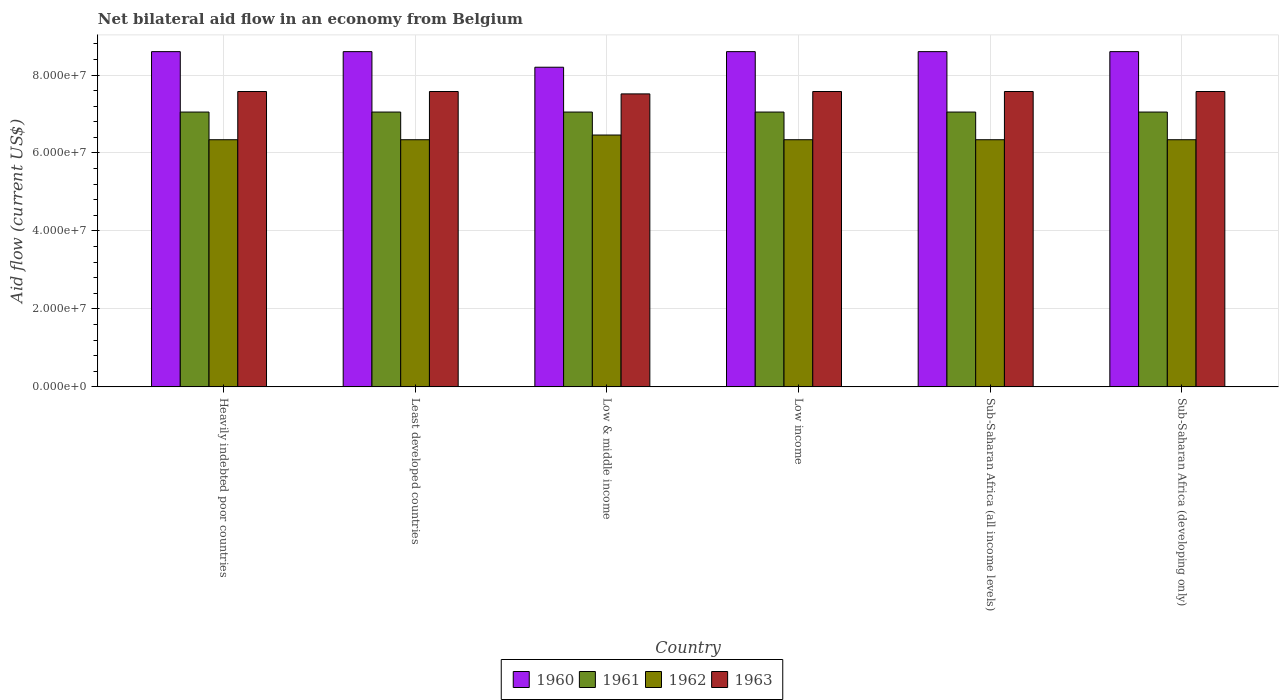Are the number of bars per tick equal to the number of legend labels?
Your answer should be compact. Yes. In how many cases, is the number of bars for a given country not equal to the number of legend labels?
Your response must be concise. 0. What is the net bilateral aid flow in 1962 in Sub-Saharan Africa (developing only)?
Provide a short and direct response. 6.34e+07. Across all countries, what is the maximum net bilateral aid flow in 1960?
Offer a very short reply. 8.60e+07. Across all countries, what is the minimum net bilateral aid flow in 1963?
Your answer should be very brief. 7.52e+07. In which country was the net bilateral aid flow in 1961 maximum?
Ensure brevity in your answer.  Heavily indebted poor countries. In which country was the net bilateral aid flow in 1960 minimum?
Offer a terse response. Low & middle income. What is the total net bilateral aid flow in 1960 in the graph?
Keep it short and to the point. 5.12e+08. What is the difference between the net bilateral aid flow in 1960 in Heavily indebted poor countries and that in Sub-Saharan Africa (developing only)?
Make the answer very short. 0. What is the difference between the net bilateral aid flow in 1962 in Sub-Saharan Africa (all income levels) and the net bilateral aid flow in 1963 in Sub-Saharan Africa (developing only)?
Offer a terse response. -1.24e+07. What is the average net bilateral aid flow in 1963 per country?
Provide a succinct answer. 7.57e+07. What is the difference between the net bilateral aid flow of/in 1963 and net bilateral aid flow of/in 1962 in Least developed countries?
Keep it short and to the point. 1.24e+07. In how many countries, is the net bilateral aid flow in 1963 greater than 24000000 US$?
Provide a succinct answer. 6. What is the ratio of the net bilateral aid flow in 1960 in Heavily indebted poor countries to that in Least developed countries?
Ensure brevity in your answer.  1. Is the net bilateral aid flow in 1962 in Sub-Saharan Africa (all income levels) less than that in Sub-Saharan Africa (developing only)?
Provide a succinct answer. No. Is the difference between the net bilateral aid flow in 1963 in Sub-Saharan Africa (all income levels) and Sub-Saharan Africa (developing only) greater than the difference between the net bilateral aid flow in 1962 in Sub-Saharan Africa (all income levels) and Sub-Saharan Africa (developing only)?
Provide a succinct answer. No. What is the difference between the highest and the second highest net bilateral aid flow in 1962?
Ensure brevity in your answer.  1.21e+06. What does the 2nd bar from the left in Sub-Saharan Africa (all income levels) represents?
Your response must be concise. 1961. Is it the case that in every country, the sum of the net bilateral aid flow in 1960 and net bilateral aid flow in 1961 is greater than the net bilateral aid flow in 1963?
Your answer should be compact. Yes. How many countries are there in the graph?
Keep it short and to the point. 6. What is the difference between two consecutive major ticks on the Y-axis?
Give a very brief answer. 2.00e+07. Does the graph contain any zero values?
Your answer should be compact. No. Where does the legend appear in the graph?
Provide a succinct answer. Bottom center. How many legend labels are there?
Your answer should be compact. 4. What is the title of the graph?
Give a very brief answer. Net bilateral aid flow in an economy from Belgium. Does "1993" appear as one of the legend labels in the graph?
Provide a short and direct response. No. What is the Aid flow (current US$) in 1960 in Heavily indebted poor countries?
Make the answer very short. 8.60e+07. What is the Aid flow (current US$) in 1961 in Heavily indebted poor countries?
Keep it short and to the point. 7.05e+07. What is the Aid flow (current US$) in 1962 in Heavily indebted poor countries?
Provide a short and direct response. 6.34e+07. What is the Aid flow (current US$) of 1963 in Heavily indebted poor countries?
Offer a very short reply. 7.58e+07. What is the Aid flow (current US$) in 1960 in Least developed countries?
Give a very brief answer. 8.60e+07. What is the Aid flow (current US$) of 1961 in Least developed countries?
Keep it short and to the point. 7.05e+07. What is the Aid flow (current US$) in 1962 in Least developed countries?
Ensure brevity in your answer.  6.34e+07. What is the Aid flow (current US$) of 1963 in Least developed countries?
Make the answer very short. 7.58e+07. What is the Aid flow (current US$) in 1960 in Low & middle income?
Your response must be concise. 8.20e+07. What is the Aid flow (current US$) in 1961 in Low & middle income?
Provide a succinct answer. 7.05e+07. What is the Aid flow (current US$) in 1962 in Low & middle income?
Your answer should be very brief. 6.46e+07. What is the Aid flow (current US$) in 1963 in Low & middle income?
Give a very brief answer. 7.52e+07. What is the Aid flow (current US$) of 1960 in Low income?
Offer a terse response. 8.60e+07. What is the Aid flow (current US$) in 1961 in Low income?
Offer a very short reply. 7.05e+07. What is the Aid flow (current US$) of 1962 in Low income?
Your answer should be very brief. 6.34e+07. What is the Aid flow (current US$) of 1963 in Low income?
Give a very brief answer. 7.58e+07. What is the Aid flow (current US$) in 1960 in Sub-Saharan Africa (all income levels)?
Give a very brief answer. 8.60e+07. What is the Aid flow (current US$) of 1961 in Sub-Saharan Africa (all income levels)?
Give a very brief answer. 7.05e+07. What is the Aid flow (current US$) of 1962 in Sub-Saharan Africa (all income levels)?
Your answer should be compact. 6.34e+07. What is the Aid flow (current US$) of 1963 in Sub-Saharan Africa (all income levels)?
Offer a terse response. 7.58e+07. What is the Aid flow (current US$) in 1960 in Sub-Saharan Africa (developing only)?
Provide a succinct answer. 8.60e+07. What is the Aid flow (current US$) in 1961 in Sub-Saharan Africa (developing only)?
Make the answer very short. 7.05e+07. What is the Aid flow (current US$) in 1962 in Sub-Saharan Africa (developing only)?
Provide a succinct answer. 6.34e+07. What is the Aid flow (current US$) in 1963 in Sub-Saharan Africa (developing only)?
Make the answer very short. 7.58e+07. Across all countries, what is the maximum Aid flow (current US$) in 1960?
Your response must be concise. 8.60e+07. Across all countries, what is the maximum Aid flow (current US$) of 1961?
Provide a succinct answer. 7.05e+07. Across all countries, what is the maximum Aid flow (current US$) of 1962?
Give a very brief answer. 6.46e+07. Across all countries, what is the maximum Aid flow (current US$) in 1963?
Your response must be concise. 7.58e+07. Across all countries, what is the minimum Aid flow (current US$) of 1960?
Your answer should be compact. 8.20e+07. Across all countries, what is the minimum Aid flow (current US$) in 1961?
Keep it short and to the point. 7.05e+07. Across all countries, what is the minimum Aid flow (current US$) in 1962?
Provide a succinct answer. 6.34e+07. Across all countries, what is the minimum Aid flow (current US$) of 1963?
Offer a terse response. 7.52e+07. What is the total Aid flow (current US$) of 1960 in the graph?
Offer a very short reply. 5.12e+08. What is the total Aid flow (current US$) of 1961 in the graph?
Offer a terse response. 4.23e+08. What is the total Aid flow (current US$) of 1962 in the graph?
Give a very brief answer. 3.82e+08. What is the total Aid flow (current US$) in 1963 in the graph?
Offer a terse response. 4.54e+08. What is the difference between the Aid flow (current US$) in 1961 in Heavily indebted poor countries and that in Least developed countries?
Your answer should be compact. 0. What is the difference between the Aid flow (current US$) of 1960 in Heavily indebted poor countries and that in Low & middle income?
Your answer should be compact. 4.00e+06. What is the difference between the Aid flow (current US$) of 1961 in Heavily indebted poor countries and that in Low & middle income?
Make the answer very short. 0. What is the difference between the Aid flow (current US$) of 1962 in Heavily indebted poor countries and that in Low & middle income?
Your answer should be very brief. -1.21e+06. What is the difference between the Aid flow (current US$) of 1963 in Heavily indebted poor countries and that in Low & middle income?
Make the answer very short. 6.10e+05. What is the difference between the Aid flow (current US$) of 1960 in Heavily indebted poor countries and that in Sub-Saharan Africa (all income levels)?
Your response must be concise. 0. What is the difference between the Aid flow (current US$) of 1962 in Least developed countries and that in Low & middle income?
Give a very brief answer. -1.21e+06. What is the difference between the Aid flow (current US$) of 1962 in Least developed countries and that in Low income?
Your answer should be very brief. 0. What is the difference between the Aid flow (current US$) of 1960 in Least developed countries and that in Sub-Saharan Africa (all income levels)?
Your answer should be very brief. 0. What is the difference between the Aid flow (current US$) in 1962 in Least developed countries and that in Sub-Saharan Africa (all income levels)?
Make the answer very short. 0. What is the difference between the Aid flow (current US$) in 1961 in Low & middle income and that in Low income?
Offer a very short reply. 0. What is the difference between the Aid flow (current US$) in 1962 in Low & middle income and that in Low income?
Your answer should be very brief. 1.21e+06. What is the difference between the Aid flow (current US$) of 1963 in Low & middle income and that in Low income?
Your response must be concise. -6.10e+05. What is the difference between the Aid flow (current US$) of 1962 in Low & middle income and that in Sub-Saharan Africa (all income levels)?
Give a very brief answer. 1.21e+06. What is the difference between the Aid flow (current US$) of 1963 in Low & middle income and that in Sub-Saharan Africa (all income levels)?
Offer a very short reply. -6.10e+05. What is the difference between the Aid flow (current US$) in 1960 in Low & middle income and that in Sub-Saharan Africa (developing only)?
Keep it short and to the point. -4.00e+06. What is the difference between the Aid flow (current US$) of 1961 in Low & middle income and that in Sub-Saharan Africa (developing only)?
Make the answer very short. 0. What is the difference between the Aid flow (current US$) of 1962 in Low & middle income and that in Sub-Saharan Africa (developing only)?
Offer a terse response. 1.21e+06. What is the difference between the Aid flow (current US$) of 1963 in Low & middle income and that in Sub-Saharan Africa (developing only)?
Your answer should be very brief. -6.10e+05. What is the difference between the Aid flow (current US$) in 1960 in Low income and that in Sub-Saharan Africa (all income levels)?
Keep it short and to the point. 0. What is the difference between the Aid flow (current US$) of 1962 in Low income and that in Sub-Saharan Africa (all income levels)?
Offer a very short reply. 0. What is the difference between the Aid flow (current US$) of 1962 in Low income and that in Sub-Saharan Africa (developing only)?
Ensure brevity in your answer.  0. What is the difference between the Aid flow (current US$) of 1960 in Heavily indebted poor countries and the Aid flow (current US$) of 1961 in Least developed countries?
Keep it short and to the point. 1.55e+07. What is the difference between the Aid flow (current US$) in 1960 in Heavily indebted poor countries and the Aid flow (current US$) in 1962 in Least developed countries?
Your response must be concise. 2.26e+07. What is the difference between the Aid flow (current US$) in 1960 in Heavily indebted poor countries and the Aid flow (current US$) in 1963 in Least developed countries?
Your response must be concise. 1.02e+07. What is the difference between the Aid flow (current US$) in 1961 in Heavily indebted poor countries and the Aid flow (current US$) in 1962 in Least developed countries?
Your response must be concise. 7.10e+06. What is the difference between the Aid flow (current US$) of 1961 in Heavily indebted poor countries and the Aid flow (current US$) of 1963 in Least developed countries?
Your response must be concise. -5.27e+06. What is the difference between the Aid flow (current US$) in 1962 in Heavily indebted poor countries and the Aid flow (current US$) in 1963 in Least developed countries?
Provide a short and direct response. -1.24e+07. What is the difference between the Aid flow (current US$) in 1960 in Heavily indebted poor countries and the Aid flow (current US$) in 1961 in Low & middle income?
Give a very brief answer. 1.55e+07. What is the difference between the Aid flow (current US$) of 1960 in Heavily indebted poor countries and the Aid flow (current US$) of 1962 in Low & middle income?
Offer a terse response. 2.14e+07. What is the difference between the Aid flow (current US$) of 1960 in Heavily indebted poor countries and the Aid flow (current US$) of 1963 in Low & middle income?
Offer a very short reply. 1.08e+07. What is the difference between the Aid flow (current US$) in 1961 in Heavily indebted poor countries and the Aid flow (current US$) in 1962 in Low & middle income?
Give a very brief answer. 5.89e+06. What is the difference between the Aid flow (current US$) of 1961 in Heavily indebted poor countries and the Aid flow (current US$) of 1963 in Low & middle income?
Keep it short and to the point. -4.66e+06. What is the difference between the Aid flow (current US$) of 1962 in Heavily indebted poor countries and the Aid flow (current US$) of 1963 in Low & middle income?
Provide a succinct answer. -1.18e+07. What is the difference between the Aid flow (current US$) in 1960 in Heavily indebted poor countries and the Aid flow (current US$) in 1961 in Low income?
Offer a terse response. 1.55e+07. What is the difference between the Aid flow (current US$) in 1960 in Heavily indebted poor countries and the Aid flow (current US$) in 1962 in Low income?
Offer a very short reply. 2.26e+07. What is the difference between the Aid flow (current US$) in 1960 in Heavily indebted poor countries and the Aid flow (current US$) in 1963 in Low income?
Ensure brevity in your answer.  1.02e+07. What is the difference between the Aid flow (current US$) in 1961 in Heavily indebted poor countries and the Aid flow (current US$) in 1962 in Low income?
Offer a terse response. 7.10e+06. What is the difference between the Aid flow (current US$) in 1961 in Heavily indebted poor countries and the Aid flow (current US$) in 1963 in Low income?
Provide a short and direct response. -5.27e+06. What is the difference between the Aid flow (current US$) in 1962 in Heavily indebted poor countries and the Aid flow (current US$) in 1963 in Low income?
Give a very brief answer. -1.24e+07. What is the difference between the Aid flow (current US$) in 1960 in Heavily indebted poor countries and the Aid flow (current US$) in 1961 in Sub-Saharan Africa (all income levels)?
Provide a succinct answer. 1.55e+07. What is the difference between the Aid flow (current US$) of 1960 in Heavily indebted poor countries and the Aid flow (current US$) of 1962 in Sub-Saharan Africa (all income levels)?
Your answer should be very brief. 2.26e+07. What is the difference between the Aid flow (current US$) in 1960 in Heavily indebted poor countries and the Aid flow (current US$) in 1963 in Sub-Saharan Africa (all income levels)?
Ensure brevity in your answer.  1.02e+07. What is the difference between the Aid flow (current US$) of 1961 in Heavily indebted poor countries and the Aid flow (current US$) of 1962 in Sub-Saharan Africa (all income levels)?
Your answer should be very brief. 7.10e+06. What is the difference between the Aid flow (current US$) in 1961 in Heavily indebted poor countries and the Aid flow (current US$) in 1963 in Sub-Saharan Africa (all income levels)?
Your response must be concise. -5.27e+06. What is the difference between the Aid flow (current US$) in 1962 in Heavily indebted poor countries and the Aid flow (current US$) in 1963 in Sub-Saharan Africa (all income levels)?
Your answer should be very brief. -1.24e+07. What is the difference between the Aid flow (current US$) of 1960 in Heavily indebted poor countries and the Aid flow (current US$) of 1961 in Sub-Saharan Africa (developing only)?
Ensure brevity in your answer.  1.55e+07. What is the difference between the Aid flow (current US$) of 1960 in Heavily indebted poor countries and the Aid flow (current US$) of 1962 in Sub-Saharan Africa (developing only)?
Your response must be concise. 2.26e+07. What is the difference between the Aid flow (current US$) in 1960 in Heavily indebted poor countries and the Aid flow (current US$) in 1963 in Sub-Saharan Africa (developing only)?
Keep it short and to the point. 1.02e+07. What is the difference between the Aid flow (current US$) in 1961 in Heavily indebted poor countries and the Aid flow (current US$) in 1962 in Sub-Saharan Africa (developing only)?
Offer a terse response. 7.10e+06. What is the difference between the Aid flow (current US$) of 1961 in Heavily indebted poor countries and the Aid flow (current US$) of 1963 in Sub-Saharan Africa (developing only)?
Make the answer very short. -5.27e+06. What is the difference between the Aid flow (current US$) of 1962 in Heavily indebted poor countries and the Aid flow (current US$) of 1963 in Sub-Saharan Africa (developing only)?
Ensure brevity in your answer.  -1.24e+07. What is the difference between the Aid flow (current US$) of 1960 in Least developed countries and the Aid flow (current US$) of 1961 in Low & middle income?
Make the answer very short. 1.55e+07. What is the difference between the Aid flow (current US$) of 1960 in Least developed countries and the Aid flow (current US$) of 1962 in Low & middle income?
Give a very brief answer. 2.14e+07. What is the difference between the Aid flow (current US$) in 1960 in Least developed countries and the Aid flow (current US$) in 1963 in Low & middle income?
Offer a terse response. 1.08e+07. What is the difference between the Aid flow (current US$) of 1961 in Least developed countries and the Aid flow (current US$) of 1962 in Low & middle income?
Provide a succinct answer. 5.89e+06. What is the difference between the Aid flow (current US$) of 1961 in Least developed countries and the Aid flow (current US$) of 1963 in Low & middle income?
Ensure brevity in your answer.  -4.66e+06. What is the difference between the Aid flow (current US$) in 1962 in Least developed countries and the Aid flow (current US$) in 1963 in Low & middle income?
Keep it short and to the point. -1.18e+07. What is the difference between the Aid flow (current US$) of 1960 in Least developed countries and the Aid flow (current US$) of 1961 in Low income?
Ensure brevity in your answer.  1.55e+07. What is the difference between the Aid flow (current US$) in 1960 in Least developed countries and the Aid flow (current US$) in 1962 in Low income?
Your answer should be compact. 2.26e+07. What is the difference between the Aid flow (current US$) in 1960 in Least developed countries and the Aid flow (current US$) in 1963 in Low income?
Your answer should be very brief. 1.02e+07. What is the difference between the Aid flow (current US$) in 1961 in Least developed countries and the Aid flow (current US$) in 1962 in Low income?
Ensure brevity in your answer.  7.10e+06. What is the difference between the Aid flow (current US$) in 1961 in Least developed countries and the Aid flow (current US$) in 1963 in Low income?
Your response must be concise. -5.27e+06. What is the difference between the Aid flow (current US$) in 1962 in Least developed countries and the Aid flow (current US$) in 1963 in Low income?
Make the answer very short. -1.24e+07. What is the difference between the Aid flow (current US$) of 1960 in Least developed countries and the Aid flow (current US$) of 1961 in Sub-Saharan Africa (all income levels)?
Provide a short and direct response. 1.55e+07. What is the difference between the Aid flow (current US$) in 1960 in Least developed countries and the Aid flow (current US$) in 1962 in Sub-Saharan Africa (all income levels)?
Offer a terse response. 2.26e+07. What is the difference between the Aid flow (current US$) in 1960 in Least developed countries and the Aid flow (current US$) in 1963 in Sub-Saharan Africa (all income levels)?
Provide a succinct answer. 1.02e+07. What is the difference between the Aid flow (current US$) in 1961 in Least developed countries and the Aid flow (current US$) in 1962 in Sub-Saharan Africa (all income levels)?
Ensure brevity in your answer.  7.10e+06. What is the difference between the Aid flow (current US$) of 1961 in Least developed countries and the Aid flow (current US$) of 1963 in Sub-Saharan Africa (all income levels)?
Offer a very short reply. -5.27e+06. What is the difference between the Aid flow (current US$) in 1962 in Least developed countries and the Aid flow (current US$) in 1963 in Sub-Saharan Africa (all income levels)?
Provide a succinct answer. -1.24e+07. What is the difference between the Aid flow (current US$) in 1960 in Least developed countries and the Aid flow (current US$) in 1961 in Sub-Saharan Africa (developing only)?
Ensure brevity in your answer.  1.55e+07. What is the difference between the Aid flow (current US$) of 1960 in Least developed countries and the Aid flow (current US$) of 1962 in Sub-Saharan Africa (developing only)?
Provide a short and direct response. 2.26e+07. What is the difference between the Aid flow (current US$) in 1960 in Least developed countries and the Aid flow (current US$) in 1963 in Sub-Saharan Africa (developing only)?
Provide a short and direct response. 1.02e+07. What is the difference between the Aid flow (current US$) of 1961 in Least developed countries and the Aid flow (current US$) of 1962 in Sub-Saharan Africa (developing only)?
Ensure brevity in your answer.  7.10e+06. What is the difference between the Aid flow (current US$) of 1961 in Least developed countries and the Aid flow (current US$) of 1963 in Sub-Saharan Africa (developing only)?
Your answer should be compact. -5.27e+06. What is the difference between the Aid flow (current US$) of 1962 in Least developed countries and the Aid flow (current US$) of 1963 in Sub-Saharan Africa (developing only)?
Offer a terse response. -1.24e+07. What is the difference between the Aid flow (current US$) of 1960 in Low & middle income and the Aid flow (current US$) of 1961 in Low income?
Offer a very short reply. 1.15e+07. What is the difference between the Aid flow (current US$) in 1960 in Low & middle income and the Aid flow (current US$) in 1962 in Low income?
Provide a short and direct response. 1.86e+07. What is the difference between the Aid flow (current US$) in 1960 in Low & middle income and the Aid flow (current US$) in 1963 in Low income?
Your answer should be compact. 6.23e+06. What is the difference between the Aid flow (current US$) in 1961 in Low & middle income and the Aid flow (current US$) in 1962 in Low income?
Ensure brevity in your answer.  7.10e+06. What is the difference between the Aid flow (current US$) of 1961 in Low & middle income and the Aid flow (current US$) of 1963 in Low income?
Your response must be concise. -5.27e+06. What is the difference between the Aid flow (current US$) in 1962 in Low & middle income and the Aid flow (current US$) in 1963 in Low income?
Your answer should be compact. -1.12e+07. What is the difference between the Aid flow (current US$) in 1960 in Low & middle income and the Aid flow (current US$) in 1961 in Sub-Saharan Africa (all income levels)?
Offer a very short reply. 1.15e+07. What is the difference between the Aid flow (current US$) in 1960 in Low & middle income and the Aid flow (current US$) in 1962 in Sub-Saharan Africa (all income levels)?
Provide a succinct answer. 1.86e+07. What is the difference between the Aid flow (current US$) of 1960 in Low & middle income and the Aid flow (current US$) of 1963 in Sub-Saharan Africa (all income levels)?
Give a very brief answer. 6.23e+06. What is the difference between the Aid flow (current US$) of 1961 in Low & middle income and the Aid flow (current US$) of 1962 in Sub-Saharan Africa (all income levels)?
Your response must be concise. 7.10e+06. What is the difference between the Aid flow (current US$) of 1961 in Low & middle income and the Aid flow (current US$) of 1963 in Sub-Saharan Africa (all income levels)?
Keep it short and to the point. -5.27e+06. What is the difference between the Aid flow (current US$) in 1962 in Low & middle income and the Aid flow (current US$) in 1963 in Sub-Saharan Africa (all income levels)?
Provide a succinct answer. -1.12e+07. What is the difference between the Aid flow (current US$) of 1960 in Low & middle income and the Aid flow (current US$) of 1961 in Sub-Saharan Africa (developing only)?
Ensure brevity in your answer.  1.15e+07. What is the difference between the Aid flow (current US$) in 1960 in Low & middle income and the Aid flow (current US$) in 1962 in Sub-Saharan Africa (developing only)?
Your response must be concise. 1.86e+07. What is the difference between the Aid flow (current US$) in 1960 in Low & middle income and the Aid flow (current US$) in 1963 in Sub-Saharan Africa (developing only)?
Offer a terse response. 6.23e+06. What is the difference between the Aid flow (current US$) of 1961 in Low & middle income and the Aid flow (current US$) of 1962 in Sub-Saharan Africa (developing only)?
Make the answer very short. 7.10e+06. What is the difference between the Aid flow (current US$) in 1961 in Low & middle income and the Aid flow (current US$) in 1963 in Sub-Saharan Africa (developing only)?
Your answer should be very brief. -5.27e+06. What is the difference between the Aid flow (current US$) of 1962 in Low & middle income and the Aid flow (current US$) of 1963 in Sub-Saharan Africa (developing only)?
Ensure brevity in your answer.  -1.12e+07. What is the difference between the Aid flow (current US$) in 1960 in Low income and the Aid flow (current US$) in 1961 in Sub-Saharan Africa (all income levels)?
Give a very brief answer. 1.55e+07. What is the difference between the Aid flow (current US$) of 1960 in Low income and the Aid flow (current US$) of 1962 in Sub-Saharan Africa (all income levels)?
Provide a succinct answer. 2.26e+07. What is the difference between the Aid flow (current US$) of 1960 in Low income and the Aid flow (current US$) of 1963 in Sub-Saharan Africa (all income levels)?
Make the answer very short. 1.02e+07. What is the difference between the Aid flow (current US$) in 1961 in Low income and the Aid flow (current US$) in 1962 in Sub-Saharan Africa (all income levels)?
Ensure brevity in your answer.  7.10e+06. What is the difference between the Aid flow (current US$) of 1961 in Low income and the Aid flow (current US$) of 1963 in Sub-Saharan Africa (all income levels)?
Keep it short and to the point. -5.27e+06. What is the difference between the Aid flow (current US$) in 1962 in Low income and the Aid flow (current US$) in 1963 in Sub-Saharan Africa (all income levels)?
Your response must be concise. -1.24e+07. What is the difference between the Aid flow (current US$) of 1960 in Low income and the Aid flow (current US$) of 1961 in Sub-Saharan Africa (developing only)?
Provide a short and direct response. 1.55e+07. What is the difference between the Aid flow (current US$) of 1960 in Low income and the Aid flow (current US$) of 1962 in Sub-Saharan Africa (developing only)?
Your answer should be compact. 2.26e+07. What is the difference between the Aid flow (current US$) of 1960 in Low income and the Aid flow (current US$) of 1963 in Sub-Saharan Africa (developing only)?
Keep it short and to the point. 1.02e+07. What is the difference between the Aid flow (current US$) in 1961 in Low income and the Aid flow (current US$) in 1962 in Sub-Saharan Africa (developing only)?
Your answer should be very brief. 7.10e+06. What is the difference between the Aid flow (current US$) in 1961 in Low income and the Aid flow (current US$) in 1963 in Sub-Saharan Africa (developing only)?
Keep it short and to the point. -5.27e+06. What is the difference between the Aid flow (current US$) in 1962 in Low income and the Aid flow (current US$) in 1963 in Sub-Saharan Africa (developing only)?
Your answer should be very brief. -1.24e+07. What is the difference between the Aid flow (current US$) of 1960 in Sub-Saharan Africa (all income levels) and the Aid flow (current US$) of 1961 in Sub-Saharan Africa (developing only)?
Your answer should be compact. 1.55e+07. What is the difference between the Aid flow (current US$) of 1960 in Sub-Saharan Africa (all income levels) and the Aid flow (current US$) of 1962 in Sub-Saharan Africa (developing only)?
Offer a very short reply. 2.26e+07. What is the difference between the Aid flow (current US$) of 1960 in Sub-Saharan Africa (all income levels) and the Aid flow (current US$) of 1963 in Sub-Saharan Africa (developing only)?
Ensure brevity in your answer.  1.02e+07. What is the difference between the Aid flow (current US$) of 1961 in Sub-Saharan Africa (all income levels) and the Aid flow (current US$) of 1962 in Sub-Saharan Africa (developing only)?
Make the answer very short. 7.10e+06. What is the difference between the Aid flow (current US$) in 1961 in Sub-Saharan Africa (all income levels) and the Aid flow (current US$) in 1963 in Sub-Saharan Africa (developing only)?
Offer a terse response. -5.27e+06. What is the difference between the Aid flow (current US$) in 1962 in Sub-Saharan Africa (all income levels) and the Aid flow (current US$) in 1963 in Sub-Saharan Africa (developing only)?
Your answer should be very brief. -1.24e+07. What is the average Aid flow (current US$) of 1960 per country?
Give a very brief answer. 8.53e+07. What is the average Aid flow (current US$) of 1961 per country?
Keep it short and to the point. 7.05e+07. What is the average Aid flow (current US$) of 1962 per country?
Provide a succinct answer. 6.36e+07. What is the average Aid flow (current US$) of 1963 per country?
Offer a terse response. 7.57e+07. What is the difference between the Aid flow (current US$) of 1960 and Aid flow (current US$) of 1961 in Heavily indebted poor countries?
Ensure brevity in your answer.  1.55e+07. What is the difference between the Aid flow (current US$) of 1960 and Aid flow (current US$) of 1962 in Heavily indebted poor countries?
Your answer should be compact. 2.26e+07. What is the difference between the Aid flow (current US$) in 1960 and Aid flow (current US$) in 1963 in Heavily indebted poor countries?
Offer a very short reply. 1.02e+07. What is the difference between the Aid flow (current US$) of 1961 and Aid flow (current US$) of 1962 in Heavily indebted poor countries?
Keep it short and to the point. 7.10e+06. What is the difference between the Aid flow (current US$) in 1961 and Aid flow (current US$) in 1963 in Heavily indebted poor countries?
Offer a very short reply. -5.27e+06. What is the difference between the Aid flow (current US$) of 1962 and Aid flow (current US$) of 1963 in Heavily indebted poor countries?
Make the answer very short. -1.24e+07. What is the difference between the Aid flow (current US$) in 1960 and Aid flow (current US$) in 1961 in Least developed countries?
Ensure brevity in your answer.  1.55e+07. What is the difference between the Aid flow (current US$) in 1960 and Aid flow (current US$) in 1962 in Least developed countries?
Ensure brevity in your answer.  2.26e+07. What is the difference between the Aid flow (current US$) of 1960 and Aid flow (current US$) of 1963 in Least developed countries?
Provide a short and direct response. 1.02e+07. What is the difference between the Aid flow (current US$) of 1961 and Aid flow (current US$) of 1962 in Least developed countries?
Keep it short and to the point. 7.10e+06. What is the difference between the Aid flow (current US$) in 1961 and Aid flow (current US$) in 1963 in Least developed countries?
Your answer should be very brief. -5.27e+06. What is the difference between the Aid flow (current US$) in 1962 and Aid flow (current US$) in 1963 in Least developed countries?
Keep it short and to the point. -1.24e+07. What is the difference between the Aid flow (current US$) in 1960 and Aid flow (current US$) in 1961 in Low & middle income?
Provide a succinct answer. 1.15e+07. What is the difference between the Aid flow (current US$) in 1960 and Aid flow (current US$) in 1962 in Low & middle income?
Make the answer very short. 1.74e+07. What is the difference between the Aid flow (current US$) in 1960 and Aid flow (current US$) in 1963 in Low & middle income?
Provide a succinct answer. 6.84e+06. What is the difference between the Aid flow (current US$) in 1961 and Aid flow (current US$) in 1962 in Low & middle income?
Offer a very short reply. 5.89e+06. What is the difference between the Aid flow (current US$) in 1961 and Aid flow (current US$) in 1963 in Low & middle income?
Your answer should be compact. -4.66e+06. What is the difference between the Aid flow (current US$) of 1962 and Aid flow (current US$) of 1963 in Low & middle income?
Provide a succinct answer. -1.06e+07. What is the difference between the Aid flow (current US$) of 1960 and Aid flow (current US$) of 1961 in Low income?
Your response must be concise. 1.55e+07. What is the difference between the Aid flow (current US$) of 1960 and Aid flow (current US$) of 1962 in Low income?
Provide a succinct answer. 2.26e+07. What is the difference between the Aid flow (current US$) in 1960 and Aid flow (current US$) in 1963 in Low income?
Make the answer very short. 1.02e+07. What is the difference between the Aid flow (current US$) of 1961 and Aid flow (current US$) of 1962 in Low income?
Offer a very short reply. 7.10e+06. What is the difference between the Aid flow (current US$) in 1961 and Aid flow (current US$) in 1963 in Low income?
Offer a very short reply. -5.27e+06. What is the difference between the Aid flow (current US$) in 1962 and Aid flow (current US$) in 1963 in Low income?
Make the answer very short. -1.24e+07. What is the difference between the Aid flow (current US$) in 1960 and Aid flow (current US$) in 1961 in Sub-Saharan Africa (all income levels)?
Provide a succinct answer. 1.55e+07. What is the difference between the Aid flow (current US$) in 1960 and Aid flow (current US$) in 1962 in Sub-Saharan Africa (all income levels)?
Offer a terse response. 2.26e+07. What is the difference between the Aid flow (current US$) in 1960 and Aid flow (current US$) in 1963 in Sub-Saharan Africa (all income levels)?
Keep it short and to the point. 1.02e+07. What is the difference between the Aid flow (current US$) of 1961 and Aid flow (current US$) of 1962 in Sub-Saharan Africa (all income levels)?
Provide a succinct answer. 7.10e+06. What is the difference between the Aid flow (current US$) in 1961 and Aid flow (current US$) in 1963 in Sub-Saharan Africa (all income levels)?
Keep it short and to the point. -5.27e+06. What is the difference between the Aid flow (current US$) of 1962 and Aid flow (current US$) of 1963 in Sub-Saharan Africa (all income levels)?
Provide a succinct answer. -1.24e+07. What is the difference between the Aid flow (current US$) of 1960 and Aid flow (current US$) of 1961 in Sub-Saharan Africa (developing only)?
Ensure brevity in your answer.  1.55e+07. What is the difference between the Aid flow (current US$) of 1960 and Aid flow (current US$) of 1962 in Sub-Saharan Africa (developing only)?
Your response must be concise. 2.26e+07. What is the difference between the Aid flow (current US$) of 1960 and Aid flow (current US$) of 1963 in Sub-Saharan Africa (developing only)?
Give a very brief answer. 1.02e+07. What is the difference between the Aid flow (current US$) of 1961 and Aid flow (current US$) of 1962 in Sub-Saharan Africa (developing only)?
Keep it short and to the point. 7.10e+06. What is the difference between the Aid flow (current US$) in 1961 and Aid flow (current US$) in 1963 in Sub-Saharan Africa (developing only)?
Provide a succinct answer. -5.27e+06. What is the difference between the Aid flow (current US$) in 1962 and Aid flow (current US$) in 1963 in Sub-Saharan Africa (developing only)?
Make the answer very short. -1.24e+07. What is the ratio of the Aid flow (current US$) in 1962 in Heavily indebted poor countries to that in Least developed countries?
Offer a terse response. 1. What is the ratio of the Aid flow (current US$) in 1963 in Heavily indebted poor countries to that in Least developed countries?
Ensure brevity in your answer.  1. What is the ratio of the Aid flow (current US$) in 1960 in Heavily indebted poor countries to that in Low & middle income?
Provide a succinct answer. 1.05. What is the ratio of the Aid flow (current US$) of 1962 in Heavily indebted poor countries to that in Low & middle income?
Ensure brevity in your answer.  0.98. What is the ratio of the Aid flow (current US$) of 1963 in Heavily indebted poor countries to that in Low & middle income?
Offer a very short reply. 1.01. What is the ratio of the Aid flow (current US$) of 1960 in Heavily indebted poor countries to that in Low income?
Offer a very short reply. 1. What is the ratio of the Aid flow (current US$) of 1962 in Heavily indebted poor countries to that in Low income?
Make the answer very short. 1. What is the ratio of the Aid flow (current US$) in 1961 in Heavily indebted poor countries to that in Sub-Saharan Africa (all income levels)?
Your response must be concise. 1. What is the ratio of the Aid flow (current US$) in 1962 in Heavily indebted poor countries to that in Sub-Saharan Africa (all income levels)?
Your response must be concise. 1. What is the ratio of the Aid flow (current US$) in 1963 in Heavily indebted poor countries to that in Sub-Saharan Africa (all income levels)?
Your answer should be very brief. 1. What is the ratio of the Aid flow (current US$) of 1960 in Heavily indebted poor countries to that in Sub-Saharan Africa (developing only)?
Provide a short and direct response. 1. What is the ratio of the Aid flow (current US$) of 1960 in Least developed countries to that in Low & middle income?
Offer a very short reply. 1.05. What is the ratio of the Aid flow (current US$) in 1961 in Least developed countries to that in Low & middle income?
Make the answer very short. 1. What is the ratio of the Aid flow (current US$) of 1962 in Least developed countries to that in Low & middle income?
Offer a terse response. 0.98. What is the ratio of the Aid flow (current US$) in 1963 in Least developed countries to that in Low & middle income?
Provide a succinct answer. 1.01. What is the ratio of the Aid flow (current US$) in 1962 in Least developed countries to that in Sub-Saharan Africa (all income levels)?
Provide a short and direct response. 1. What is the ratio of the Aid flow (current US$) of 1961 in Least developed countries to that in Sub-Saharan Africa (developing only)?
Make the answer very short. 1. What is the ratio of the Aid flow (current US$) in 1962 in Least developed countries to that in Sub-Saharan Africa (developing only)?
Make the answer very short. 1. What is the ratio of the Aid flow (current US$) of 1963 in Least developed countries to that in Sub-Saharan Africa (developing only)?
Your answer should be compact. 1. What is the ratio of the Aid flow (current US$) of 1960 in Low & middle income to that in Low income?
Your answer should be compact. 0.95. What is the ratio of the Aid flow (current US$) in 1962 in Low & middle income to that in Low income?
Ensure brevity in your answer.  1.02. What is the ratio of the Aid flow (current US$) in 1960 in Low & middle income to that in Sub-Saharan Africa (all income levels)?
Offer a very short reply. 0.95. What is the ratio of the Aid flow (current US$) in 1962 in Low & middle income to that in Sub-Saharan Africa (all income levels)?
Make the answer very short. 1.02. What is the ratio of the Aid flow (current US$) of 1960 in Low & middle income to that in Sub-Saharan Africa (developing only)?
Make the answer very short. 0.95. What is the ratio of the Aid flow (current US$) in 1961 in Low & middle income to that in Sub-Saharan Africa (developing only)?
Provide a succinct answer. 1. What is the ratio of the Aid flow (current US$) of 1962 in Low & middle income to that in Sub-Saharan Africa (developing only)?
Give a very brief answer. 1.02. What is the ratio of the Aid flow (current US$) in 1963 in Low & middle income to that in Sub-Saharan Africa (developing only)?
Your response must be concise. 0.99. What is the ratio of the Aid flow (current US$) of 1962 in Low income to that in Sub-Saharan Africa (all income levels)?
Your response must be concise. 1. What is the ratio of the Aid flow (current US$) in 1963 in Low income to that in Sub-Saharan Africa (all income levels)?
Make the answer very short. 1. What is the ratio of the Aid flow (current US$) of 1962 in Low income to that in Sub-Saharan Africa (developing only)?
Keep it short and to the point. 1. What is the ratio of the Aid flow (current US$) in 1960 in Sub-Saharan Africa (all income levels) to that in Sub-Saharan Africa (developing only)?
Your answer should be compact. 1. What is the ratio of the Aid flow (current US$) of 1962 in Sub-Saharan Africa (all income levels) to that in Sub-Saharan Africa (developing only)?
Give a very brief answer. 1. What is the ratio of the Aid flow (current US$) of 1963 in Sub-Saharan Africa (all income levels) to that in Sub-Saharan Africa (developing only)?
Ensure brevity in your answer.  1. What is the difference between the highest and the second highest Aid flow (current US$) in 1960?
Your response must be concise. 0. What is the difference between the highest and the second highest Aid flow (current US$) in 1962?
Your answer should be compact. 1.21e+06. What is the difference between the highest and the second highest Aid flow (current US$) in 1963?
Ensure brevity in your answer.  0. What is the difference between the highest and the lowest Aid flow (current US$) in 1961?
Keep it short and to the point. 0. What is the difference between the highest and the lowest Aid flow (current US$) of 1962?
Offer a very short reply. 1.21e+06. 